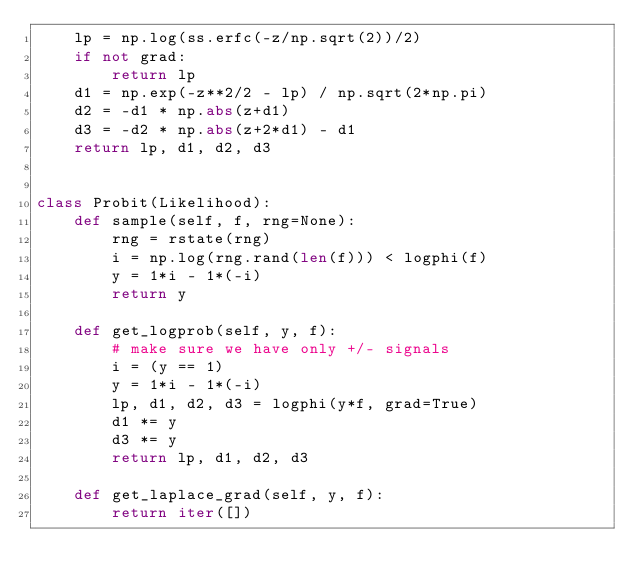Convert code to text. <code><loc_0><loc_0><loc_500><loc_500><_Python_>    lp = np.log(ss.erfc(-z/np.sqrt(2))/2)
    if not grad:
        return lp
    d1 = np.exp(-z**2/2 - lp) / np.sqrt(2*np.pi)
    d2 = -d1 * np.abs(z+d1)
    d3 = -d2 * np.abs(z+2*d1) - d1
    return lp, d1, d2, d3


class Probit(Likelihood):
    def sample(self, f, rng=None):
        rng = rstate(rng)
        i = np.log(rng.rand(len(f))) < logphi(f)
        y = 1*i - 1*(-i)
        return y

    def get_logprob(self, y, f):
        # make sure we have only +/- signals
        i = (y == 1)
        y = 1*i - 1*(-i)
        lp, d1, d2, d3 = logphi(y*f, grad=True)
        d1 *= y
        d3 *= y
        return lp, d1, d2, d3

    def get_laplace_grad(self, y, f):
        return iter([])
</code> 